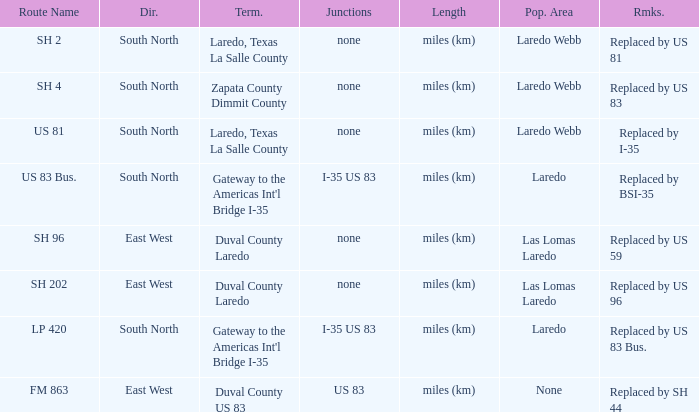Which routes have  "replaced by US 81" listed in their remarks section? SH 2. 